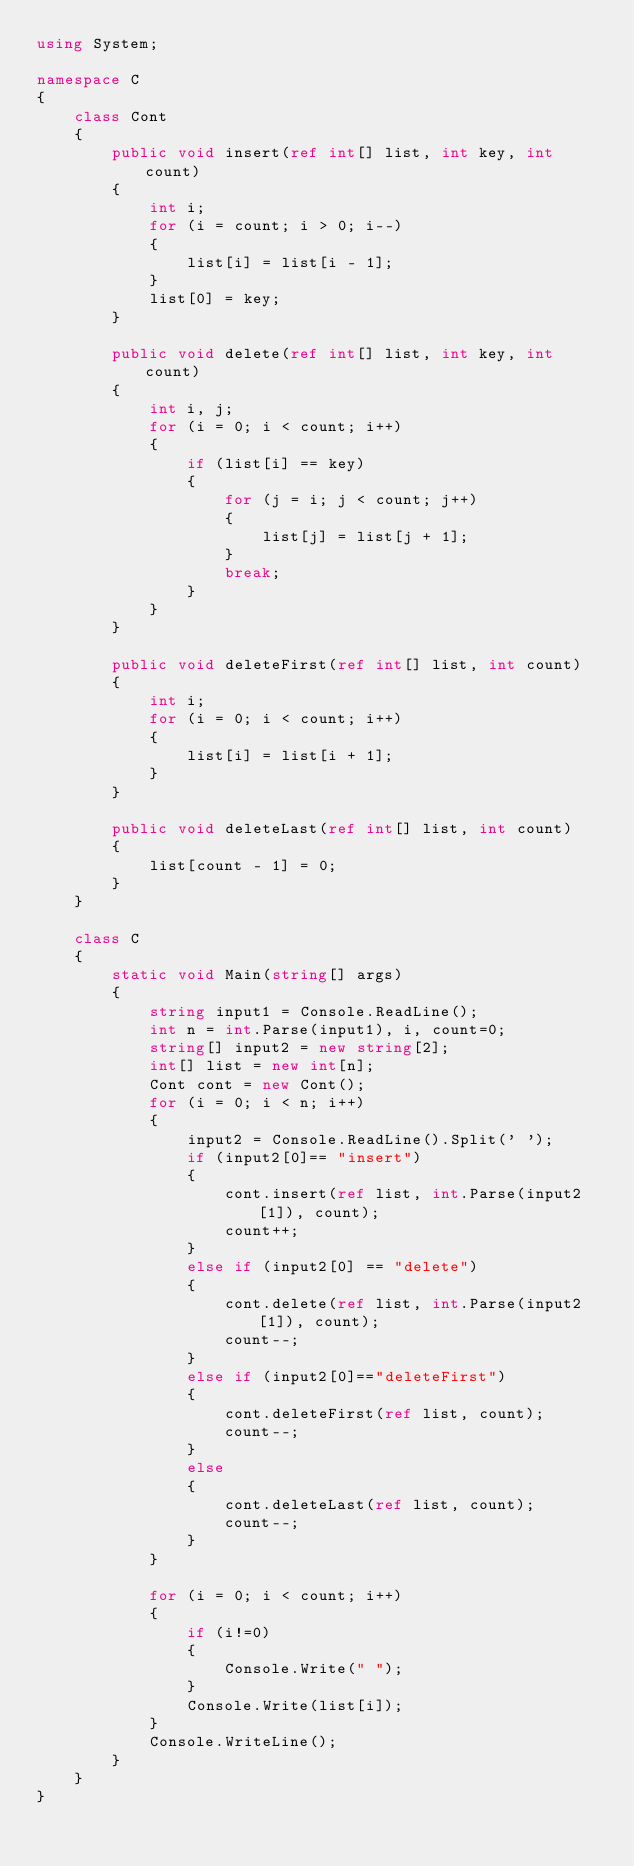<code> <loc_0><loc_0><loc_500><loc_500><_C#_>using System;

namespace C
{
    class Cont
    {
        public void insert(ref int[] list, int key, int count)
        {
            int i;
            for (i = count; i > 0; i--)
            {
                list[i] = list[i - 1];
            }
            list[0] = key;
        }

        public void delete(ref int[] list, int key, int count)
        {
            int i, j;
            for (i = 0; i < count; i++)
            {
                if (list[i] == key)
                {
                    for (j = i; j < count; j++)
                    {
                        list[j] = list[j + 1];
                    }
                    break;
                }
            }
        }

        public void deleteFirst(ref int[] list, int count)
        {
            int i;
            for (i = 0; i < count; i++)
            {
                list[i] = list[i + 1];
            }
        }

        public void deleteLast(ref int[] list, int count)
        {
            list[count - 1] = 0;
        }
    }

    class C
    {
        static void Main(string[] args)
        {
            string input1 = Console.ReadLine();
            int n = int.Parse(input1), i, count=0;
            string[] input2 = new string[2];
            int[] list = new int[n];
            Cont cont = new Cont();
            for (i = 0; i < n; i++)
            {
                input2 = Console.ReadLine().Split(' ');
                if (input2[0]== "insert")
                {
                    cont.insert(ref list, int.Parse(input2[1]), count);
                    count++;
                }
                else if (input2[0] == "delete")
                {
                    cont.delete(ref list, int.Parse(input2[1]), count);
                    count--;
                }
                else if (input2[0]=="deleteFirst")
                {
                    cont.deleteFirst(ref list, count);
                    count--;
                }
                else
                {
                    cont.deleteLast(ref list, count);
                    count--;
                }
            }

            for (i = 0; i < count; i++)
            {
                if (i!=0)
                {
                    Console.Write(" ");
                }
                Console.Write(list[i]);
            }
            Console.WriteLine();
        }
    }
}

</code> 